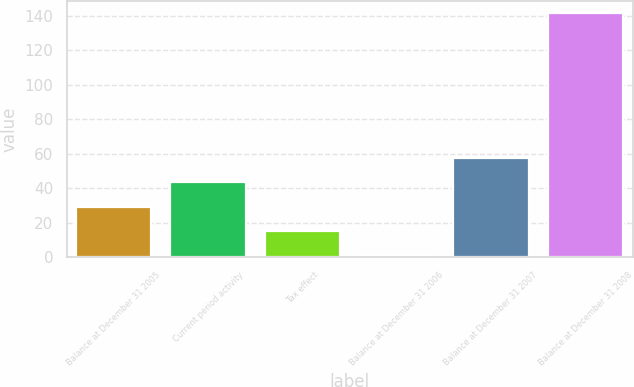Convert chart. <chart><loc_0><loc_0><loc_500><loc_500><bar_chart><fcel>Balance at December 31 2005<fcel>Current period activity<fcel>Tax effect<fcel>Balance at December 31 2006<fcel>Balance at December 31 2007<fcel>Balance at December 31 2008<nl><fcel>29.42<fcel>43.43<fcel>15.41<fcel>1.4<fcel>57.44<fcel>141.5<nl></chart> 